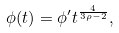Convert formula to latex. <formula><loc_0><loc_0><loc_500><loc_500>\phi ( t ) = \phi ^ { \prime } t ^ { \frac { 4 } { 3 \rho - 2 } } ,</formula> 